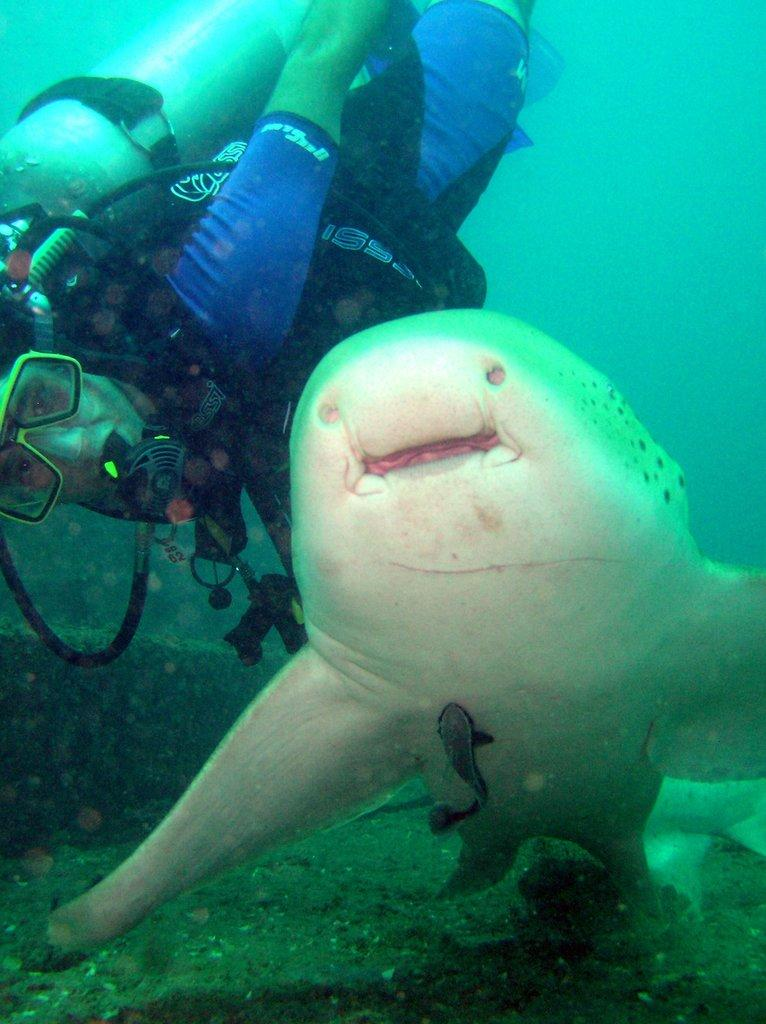What type of environment is shown in the image? The image depicts an underwater environment. What type of marine life can be seen in the image? There is a fish and a shark in the image. Is there a human presence in the image? Yes, there is a person in the image. What equipment is the person using to breathe underwater? The person is equipped with a scuba tank. What book is the person reading underwater in the image? There is no book or reading activity depicted in the image; the person is equipped with a scuba tank for breathing underwater. 